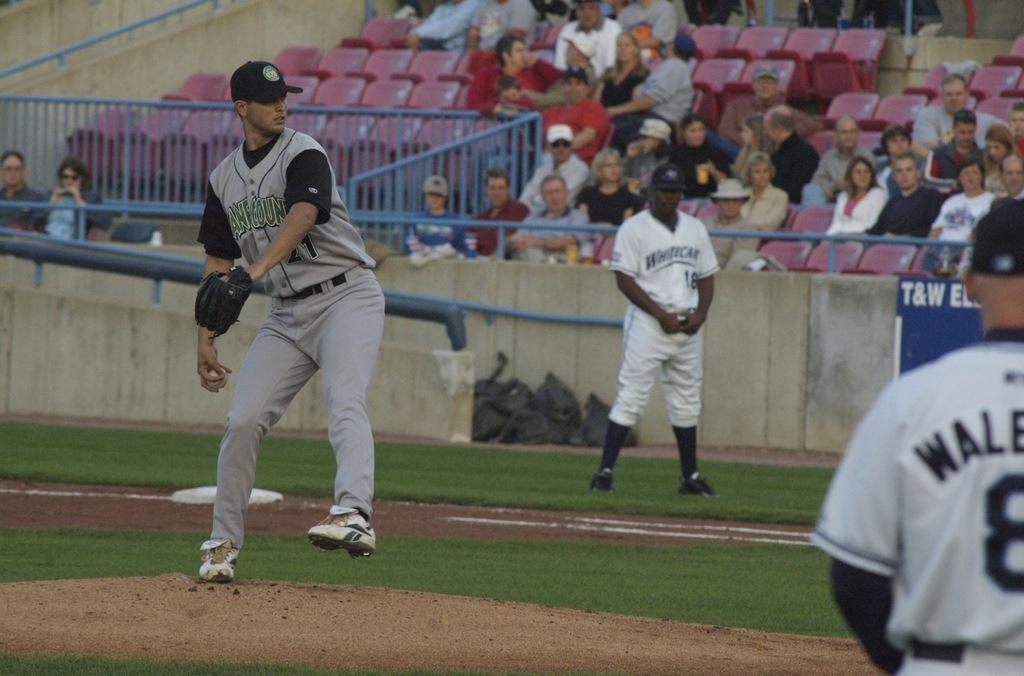Provide a one-sentence caption for the provided image. A baseball game is underway and a blue sign says T&W. 